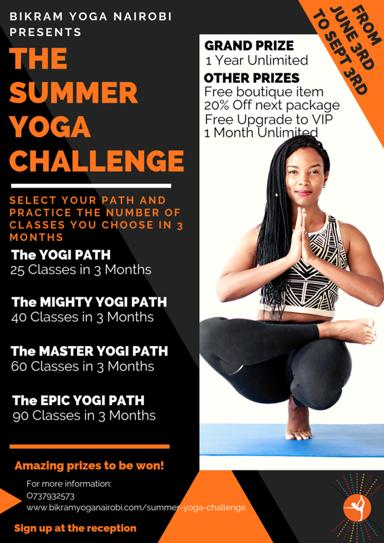What are some of the prizes available for participants in the challenge? Participants stand a chance to win spectacular prizes including a grand prize of 1-year unlimited access to yoga sessions, alongside other delightful rewards such as a boutique item, 20% discount on the next package, and an exclusive free upgrade to a VIP 1-month unlimited yoga experience. These prizes are designed to motivate and reward the dedication of participants. 